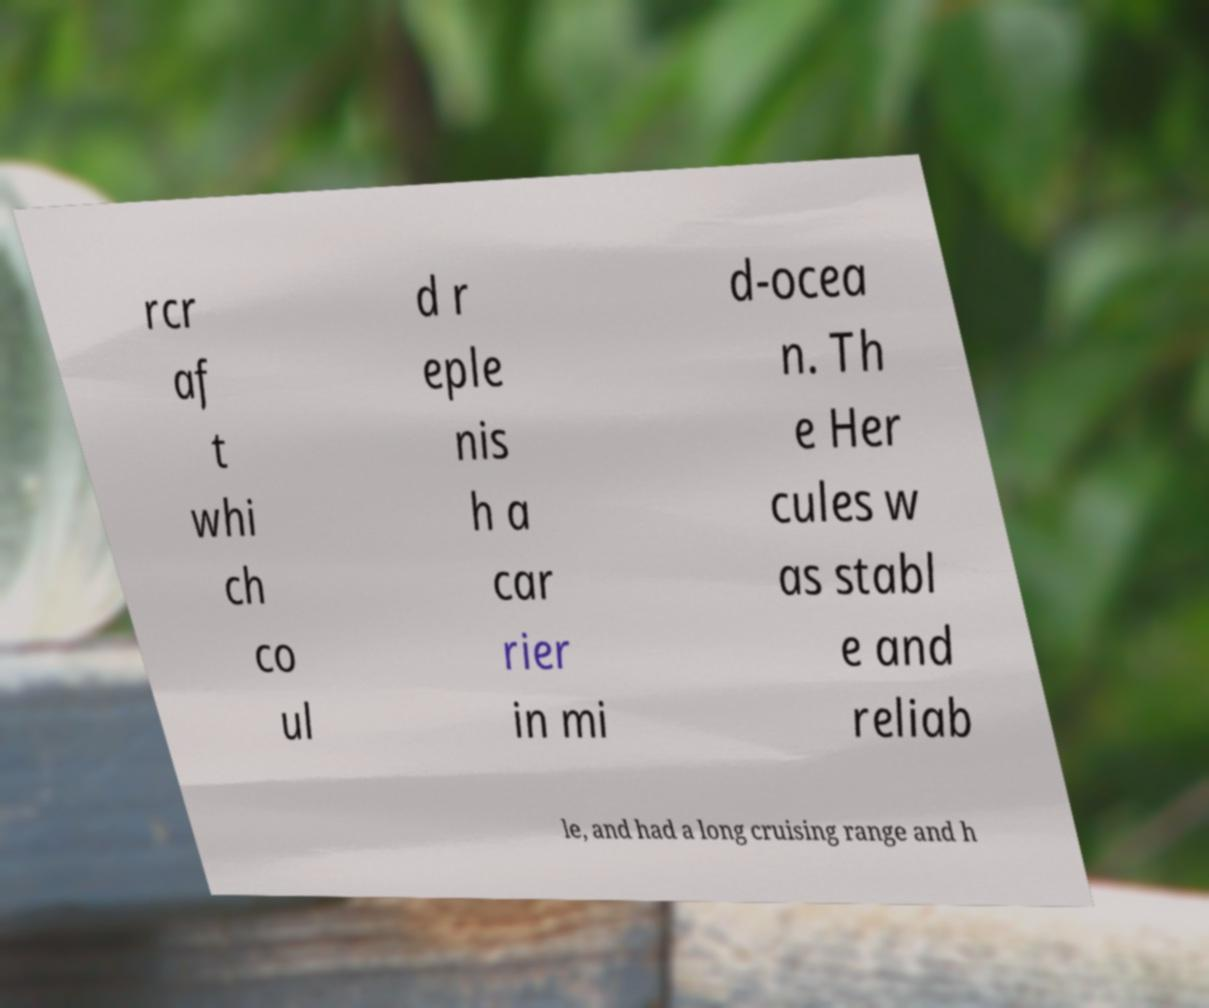Please read and relay the text visible in this image. What does it say? rcr af t whi ch co ul d r eple nis h a car rier in mi d-ocea n. Th e Her cules w as stabl e and reliab le, and had a long cruising range and h 